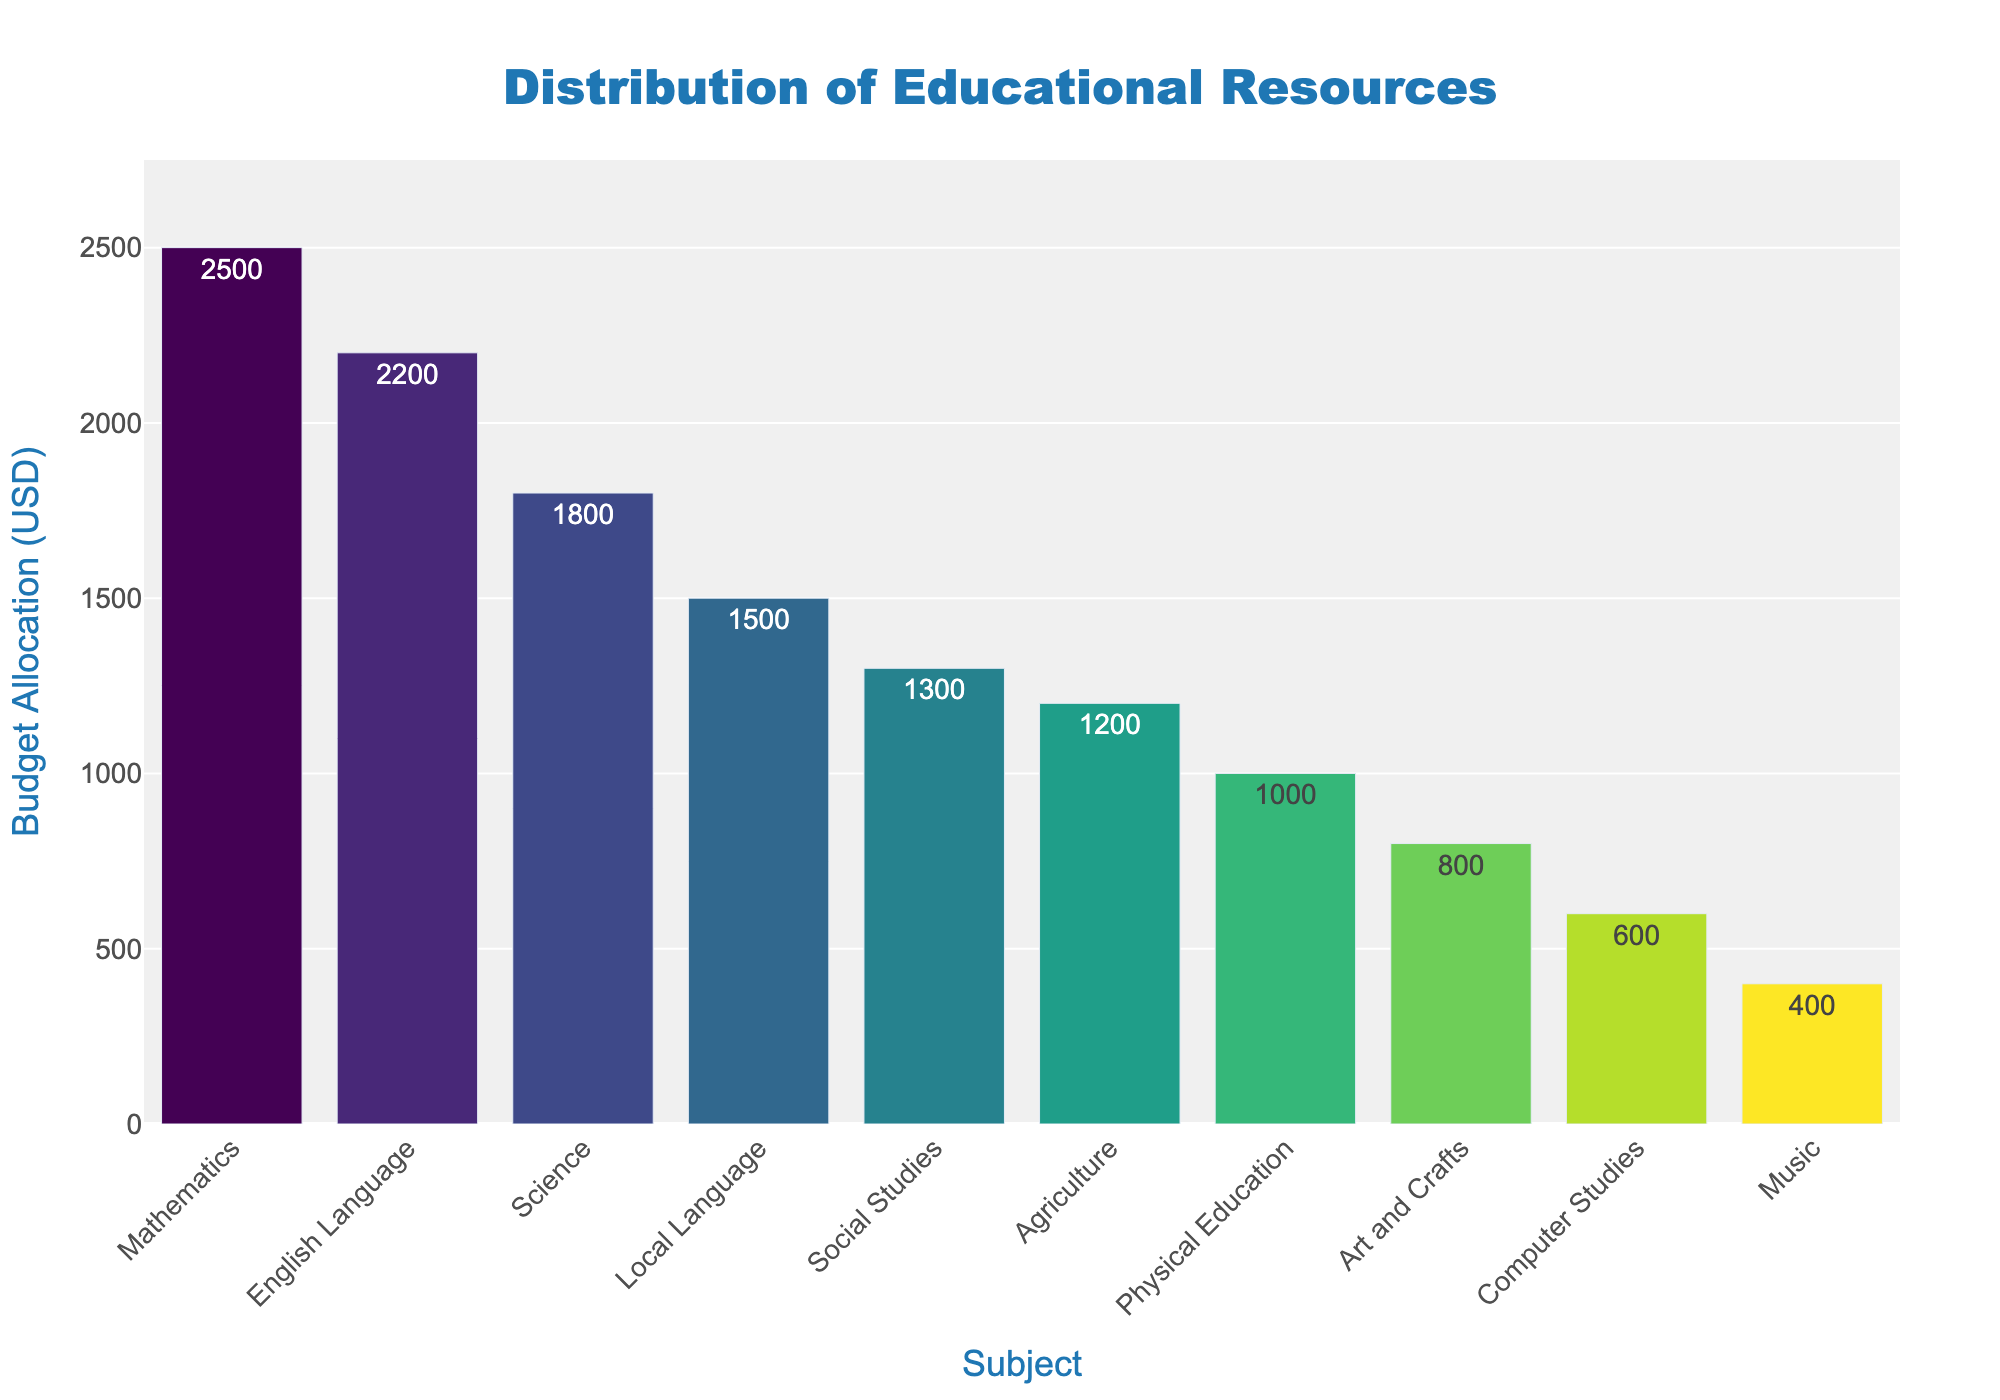Which subject has the highest budget allocation? The subject with the tallest bar represents the highest budget allocation. Mathematics has the highest bar in the chart.
Answer: Mathematics Which subject has the lowest budget allocation? The subject with the shortest bar represents the lowest budget allocation. Music has the shortest bar in the chart.
Answer: Music What is the total budget allocated to Mathematics, English Language, and Science? Add the budget allocations for Mathematics, English Language, and Science. 2500 (Mathematics) + 2200 (English Language) + 1800 (Science) = 6500.
Answer: 6500 How much more budget is allocated to Mathematics compared to Music? Subtract the budget allocation of Music from Mathematics. 2500 (Mathematics) - 400 (Music) = 2100.
Answer: 2100 What is the average budget allocation across all subjects? Sum the budget allocations for all subjects and divide by the number of subjects. (2500 + 2200 + 1800 + 1500 + 1300 + 1000 + 800 + 1200 + 600 + 400)/10 = 13300/10 = 1330.
Answer: 1330 Which subject(s) have a budget allocation above 2000 USD? Identify the subjects with bars exceeding the 2000 USD mark on the y-axis. Only Mathematics and English Language exceed this mark.
Answer: Mathematics, English Language What is the difference between the highest and lowest budget allocations? Subtract the lowest budget allocation (Music) from the highest budget allocation (Mathematics). 2500 (Mathematics) - 400 (Music) = 2100.
Answer: 2100 Which subject is allocated exactly 1500 USD? Find the bar that matches the 1500 USD label on the y-axis. Local Language has exactly 1500 USD allocation.
Answer: Local Language What is the combined budget for Art and Crafts, Agriculture, and Computer Studies? Add the budget allocations for Art and Crafts, Agriculture, and Computer Studies. 800 (Art and Crafts) + 1200 (Agriculture) + 600 (Computer Studies) = 2600.
Answer: 2600 How many subjects have a budget allocation below 1000 USD? Count the number of bars that fall below the 1000 USD mark on the y-axis. Physical Education (1000), Computer Studies (600), and Music (400) are below 1000 USD. Only Music and Computer Studies meet the criteria fully.
Answer: 2 